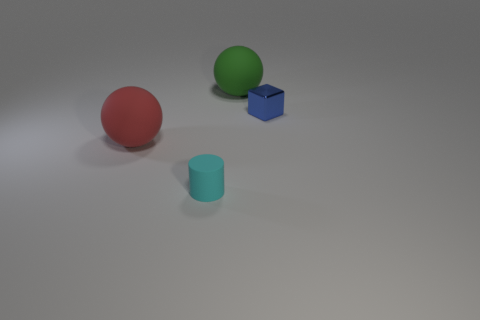Add 3 big cyan spheres. How many objects exist? 7 Subtract all blocks. How many objects are left? 3 Subtract 0 yellow cubes. How many objects are left? 4 Subtract all big green matte objects. Subtract all purple rubber cylinders. How many objects are left? 3 Add 2 red matte spheres. How many red matte spheres are left? 3 Add 1 tiny cylinders. How many tiny cylinders exist? 2 